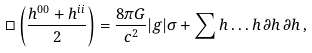Convert formula to latex. <formula><loc_0><loc_0><loc_500><loc_500>\Box \left ( \frac { h ^ { 0 0 } + h ^ { i i } } { 2 } \right ) = \frac { 8 \pi G } { c ^ { 2 } } | g | \sigma + \sum h \dots h \, \partial h \, \partial h \, ,</formula> 